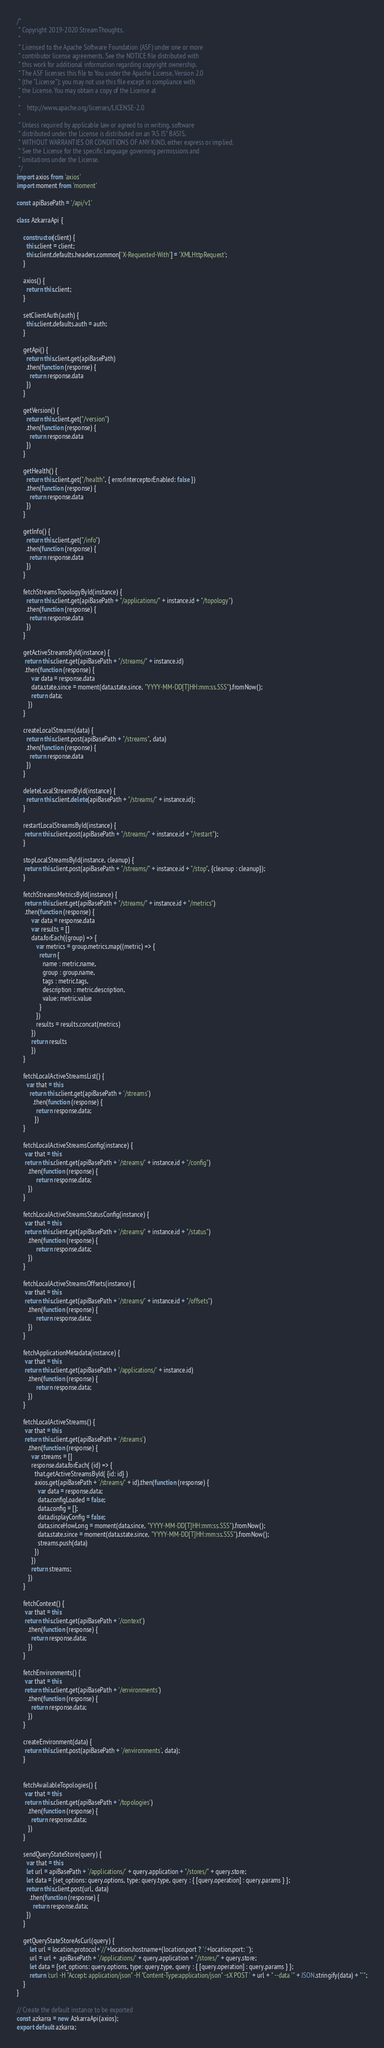<code> <loc_0><loc_0><loc_500><loc_500><_JavaScript_>/*
 * Copyright 2019-2020 StreamThoughts.
 *
 * Licensed to the Apache Software Foundation (ASF) under one or more
 * contributor license agreements. See the NOTICE file distributed with
 * this work for additional information regarding copyright ownership.
 * The ASF licenses this file to You under the Apache License, Version 2.0
 * (the "License"); you may not use this file except in compliance with
 * the License. You may obtain a copy of the License at
 *
 *    http://www.apache.org/licenses/LICENSE-2.0
 *
 * Unless required by applicable law or agreed to in writing, software
 * distributed under the License is distributed on an "AS IS" BASIS,
 * WITHOUT WARRANTIES OR CONDITIONS OF ANY KIND, either express or implied.
 * See the License for the specific language governing permissions and
 * limitations under the License.
 */
import axios from 'axios'
import moment from 'moment'

const apiBasePath = '/api/v1'

class AzkarraApi {

    constructor(client) {
      this.client = client;
      this.client.defaults.headers.common['X-Requested-With'] = 'XMLHttpRequest';
    }

    axios() {
      return this.client;
    }

    setClientAuth(auth) {
      this.client.defaults.auth = auth;
    }

    getApi() {
      return this.client.get(apiBasePath)
      .then(function (response) {
        return response.data
      })
    }

    getVersion() {
      return this.client.get("/version")
      .then(function (response) {
        return response.data
      })
    }

    getHealth() {
      return this.client.get("/health", { errorInterceptorEnabled: false })
      .then(function (response) {
        return response.data
      })
    }

    getInfo() {
      return this.client.get("/info")
      .then(function (response) {
        return response.data
      })
    }

    fetchStreamsTopologyById(instance) {
      return this.client.get(apiBasePath + "/applications/" + instance.id + "/topology")
      .then(function (response) {
        return response.data
      })
    }

    getActiveStreamsById(instance) {
     return this.client.get(apiBasePath + "/streams/" + instance.id)
     .then(function (response) {
         var data = response.data
         data.state.since = moment(data.state.since, "YYYY-MM-DD[T]HH:mm:ss.SSS").fromNow();
         return data;
       })
    }

    createLocalStreams(data) {
      return this.client.post(apiBasePath + "/streams", data)
      .then(function (response) {
        return response.data
      })
    }

    deleteLocalStreamsById(instance) {
      return this.client.delete(apiBasePath + "/streams/" + instance.id);
    }

    restartLocalStreamsById(instance) {
     return this.client.post(apiBasePath + "/streams/" + instance.id + "/restart");
    }

    stopLocalStreamsById(instance, cleanup) {
     return this.client.post(apiBasePath + "/streams/" + instance.id + "/stop", {cleanup : cleanup});
    }

    fetchStreamsMetricsById(instance) {
     return this.client.get(apiBasePath + "/streams/" + instance.id + "/metrics")
     .then(function (response) {
         var data = response.data
         var results = []
         data.forEach((group) => {
            var metrics = group.metrics.map((metric) => {
              return {
                name : metric.name,
                group : group.name,
                tags : metric.tags,
                description : metric.description,
                value: metric.value
              }
            })
            results = results.concat(metrics)
         })
         return results
         })
    }

    fetchLocalActiveStreamsList() {
      var that = this
        return this.client.get(apiBasePath + '/streams')
          .then(function (response) {
            return response.data;
           })
    }

    fetchLocalActiveStreamsConfig(instance) {
     var that = this
     return this.client.get(apiBasePath + '/streams/' + instance.id + "/config")
       .then(function (response) {
            return response.data;
       })
    }

    fetchLocalActiveStreamsStatusConfig(instance) {
     var that = this
     return this.client.get(apiBasePath + '/streams/' + instance.id + "/status")
       .then(function (response) {
            return response.data;
       })
    }

    fetchLocalActiveStreamsOffsets(instance) {
     var that = this
     return this.client.get(apiBasePath + '/streams/' + instance.id + "/offsets")
       .then(function (response) {
            return response.data;
       })
    }

    fetchApplicationMetadata(instance) {
     var that = this
     return this.client.get(apiBasePath + '/applications/' + instance.id)
       .then(function (response) {
            return response.data;
       })
    }

    fetchLocalActiveStreams() {
     var that = this
     return this.client.get(apiBasePath + '/streams')
       .then(function (response) {
         var streams = []
         response.data.forEach( (id) => {
           that.getActiveStreamsById( {id: id} )
           axios.get(apiBasePath + '/streams/' + id).then(function (response) {
             var data = response.data;
             data.configLoaded = false;
             data.config = [];
             data.displayConfig = false;
             data.sinceHowLong = moment(data.since, "YYYY-MM-DD[T]HH:mm:ss.SSS").fromNow();
             data.state.since = moment(data.state.since, "YYYY-MM-DD[T]HH:mm:ss.SSS").fromNow();
             streams.push(data)
           })
         })
         return streams;
       })
    }

    fetchContext() {
     var that = this
     return this.client.get(apiBasePath + '/context')
       .then(function (response) {
         return response.data;
       })
    }

    fetchEnvironments() {
     var that = this
     return this.client.get(apiBasePath + '/environments')
       .then(function (response) {
         return response.data;
       })
    }

    createEnvironment(data) {
     return this.client.post(apiBasePath + '/environments', data);
    }


    fetchAvailableTopologies() {
     var that = this
     return this.client.get(apiBasePath + '/topologies')
       .then(function (response) {
         return response.data;
       })
    }

    sendQueryStateStore(query) {
      var that = this
      let url = apiBasePath + '/applications/' + query.application + "/stores/" + query.store;
      let data = {set_options: query.options, type: query.type, query : { [query.operation] : query.params } };
      return this.client.post(url, data)
        .then(function (response) {
          return response.data;
      })
    }

    getQueryStateStoreAsCurl(query) {
        let url = location.protocol+'//'+location.hostname+(location.port ? ':'+location.port: '');
        url = url +  apiBasePath + '/applications/' + query.application + "/stores/" + query.store;
        let data = {set_options: query.options, type: query.type, query : { [query.operation] : query.params } };
        return 'curl -H "Accept: application/json" -H "Content-Type:application/json" -sX POST ' + url + " --data '" + JSON.stringify(data) + "'";
    }
}

// Create the default instance to be exported
const azkarra = new AzkarraApi(axios);
export default azkarra;</code> 